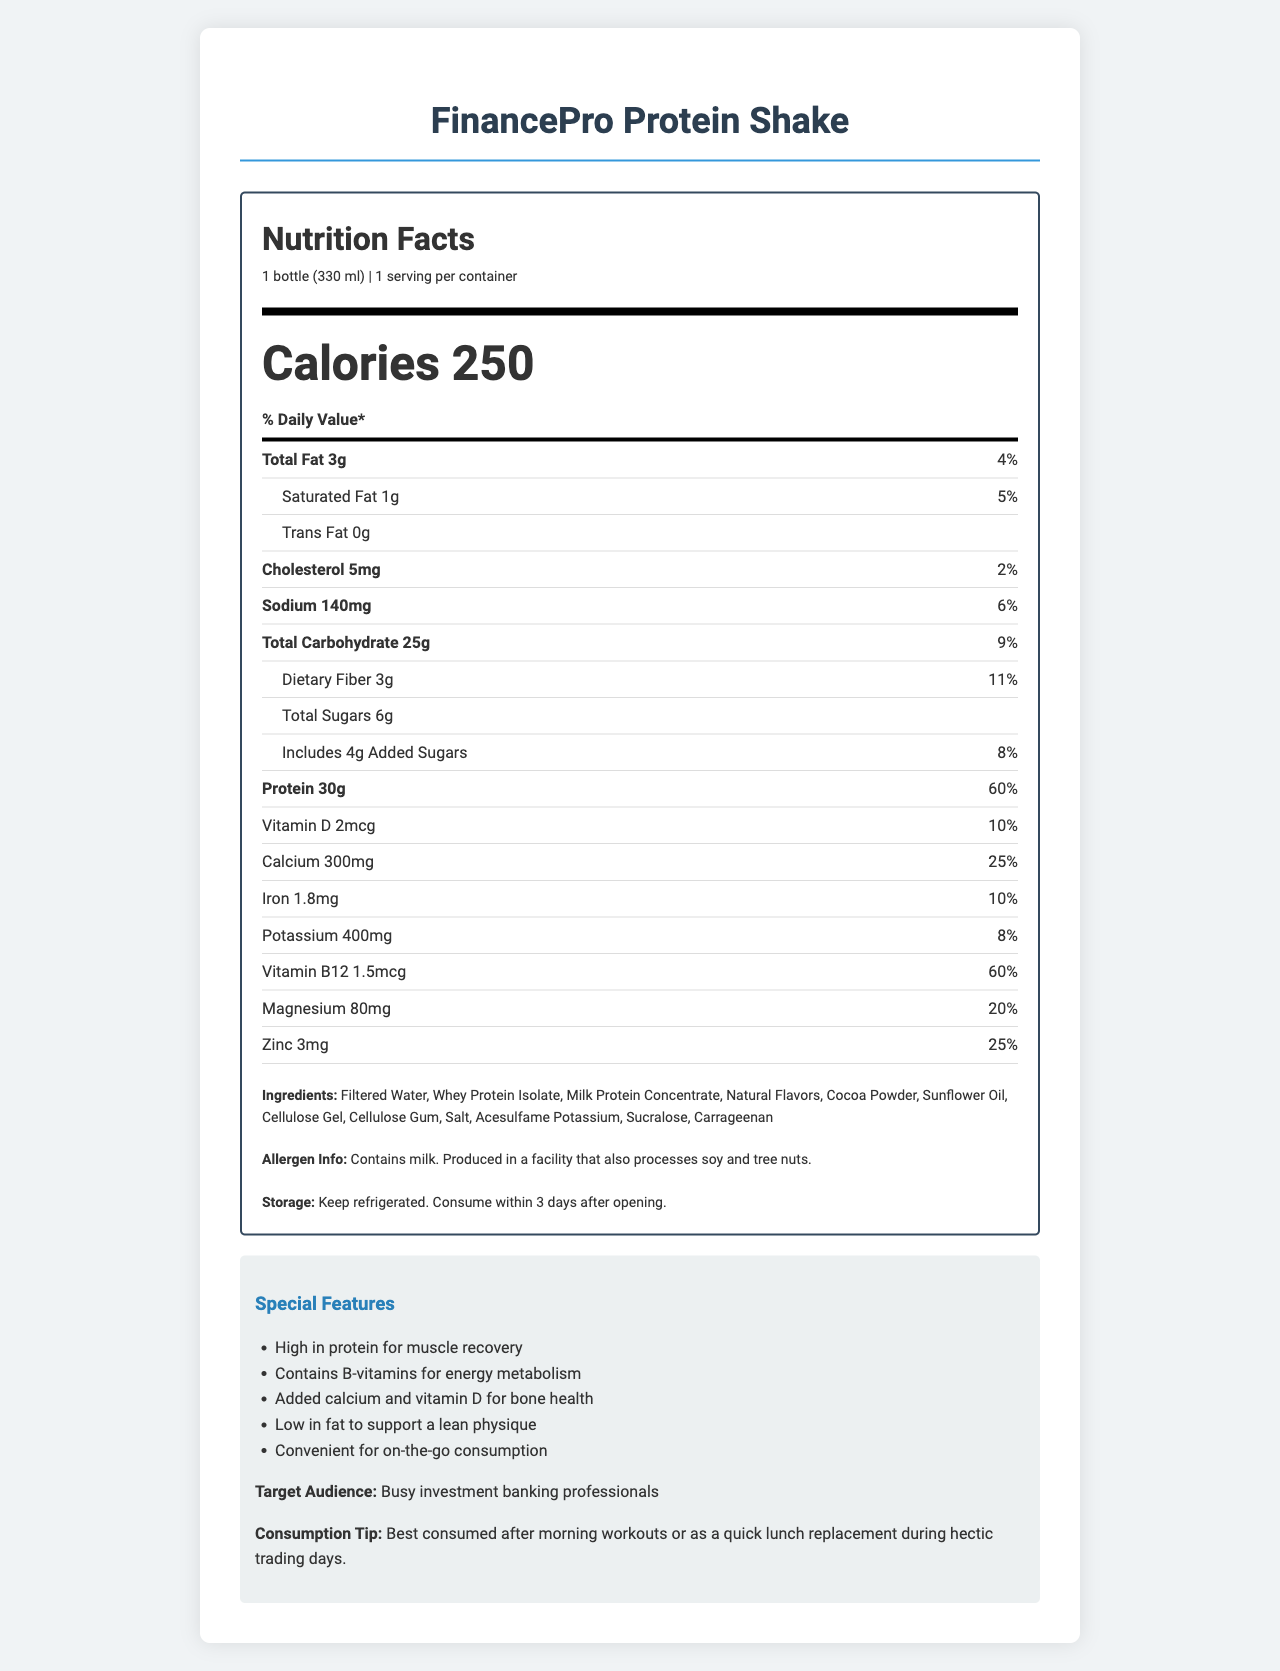what is the serving size? The serving size is listed at the beginning of the nutrition facts under the product name.
Answer: 1 bottle (330 ml) how many calories are in one serving of FinancePro Protein Shake? The document specifies that the product contains 250 calories per serving.
Answer: 250 what percentage of the daily value of protein does one serving provide? The nutrition label indicates that one serving provides 60% of the daily value for protein.
Answer: 60% how much total fat is in one serving, and what percentage of the daily value does this represent? The label states that one serving contains 3g of total fat, which is 4% of the daily value.
Answer: 3g, 4% what are the ingredients in the FinancePro Protein Shake? The ingredients are listed in the ingredients section of the nutrition label.
Answer: Filtered Water, Whey Protein Isolate, Milk Protein Concentrate, Natural Flavors, Cocoa Powder, Sunflower Oil, Cellulose Gel, Cellulose Gum, Salt, Acesulfame Potassium, Sucralose, Carrageenan what is the sodium content of the FinancePro Protein Shake? The label shows that the sodium content is 140mg per serving.
Answer: 140mg which vitamin provides the highest percentage of the daily value in the FinancePro Protein Shake? A. Vitamin D B. Vitamin B12 C. Calcium The label indicates that Vitamin B12 provides 60% of the daily value, which is the highest percentage among the listed vitamins.
Answer: B. Vitamin B12 how many grams of dietary fiber are in one serving? A. 1g B. 3g C. 5g The label shows that one serving contains 3g of dietary fiber.
Answer: B. 3g does the FinancePro Protein Shake contain any allergens? The allergen info section specifies that the product contains milk and is produced in a facility that processes soy and tree nuts.
Answer: Yes describe the main features of the FinancePro Protein Shake. The special features and target audience section provide a detailed description of the main features and intended users of the product.
Answer: The FinancePro Protein Shake is high in protein, contains B-vitamins for energy metabolism, added calcium and vitamin D for bone health, low in fat, and is convenient for on-the-go consumption. It targets busy investment banking professionals and is best consumed after morning workouts or as a quick lunch replacement during hectic trading days. what company manufactures the FinancePro Protein Shake? The manufacturer is listed at the bottom of the label.
Answer: NutriTech Solutions, Inc. how long can the FinancePro Protein Shake be consumed after opening if kept refrigerated? The storage instructions section states that the shake should be consumed within 3 days after opening if kept refrigerated.
Answer: 3 days can the exact origin of the protein used in the FinancePro Protein Shake be determined from the label? The label lists the types of protein (Whey Protein Isolate, Milk Protein Concentrate) but does not specify their exact origin or source.
Answer: Cannot be determined 